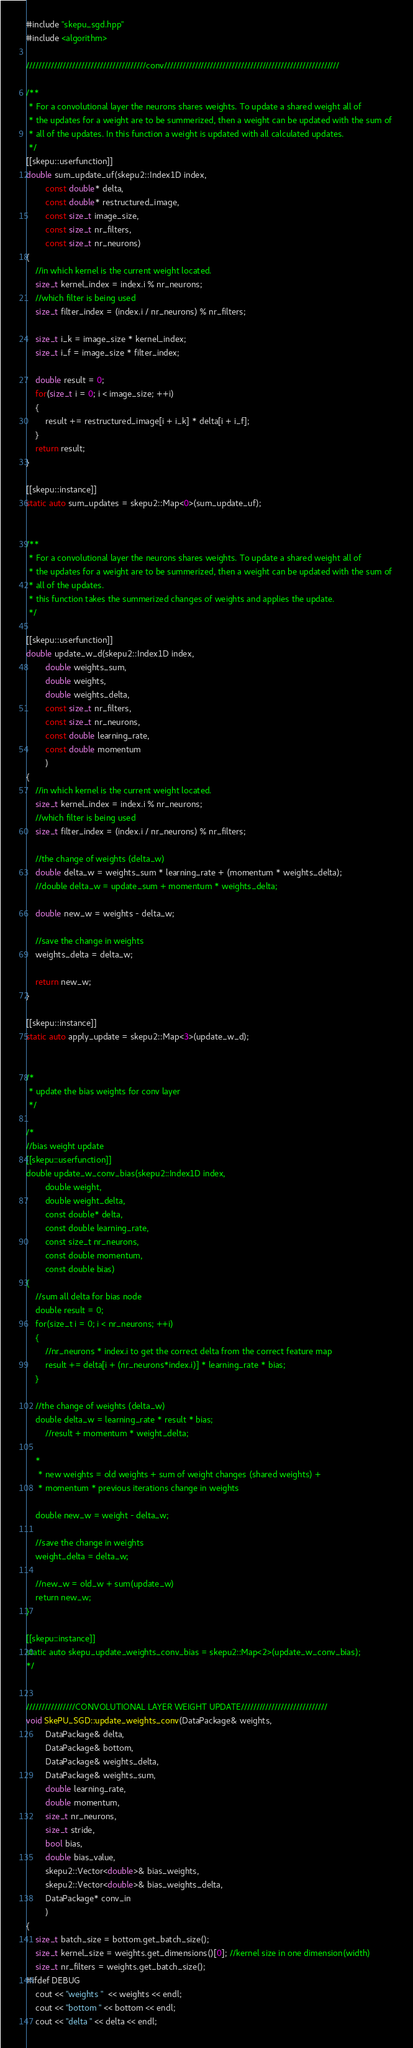<code> <loc_0><loc_0><loc_500><loc_500><_C++_>#include "skepu_sgd.hpp"
#include <algorithm>

///////////////////////////////////////conv/////////////////////////////////////////////////////////

/**
 * For a convolutional layer the neurons shares weights. To update a shared weight all of
 * the updates for a weight are to be summerized, then a weight can be updated with the sum of 
 * all of the updates. In this function a weight is updated with all calculated updates.
 */
[[skepu::userfunction]]
double sum_update_uf(skepu2::Index1D index, 
		const double* delta, 
		const double* restructured_image,
        const size_t image_size,
		const size_t nr_filters,
		const size_t nr_neurons)
{
	//in which kernel is the current weight located.
	size_t kernel_index = index.i % nr_neurons;
	//which filter is being used
	size_t filter_index = (index.i / nr_neurons) % nr_filters;

    size_t i_k = image_size * kernel_index;
    size_t i_f = image_size * filter_index;

	double result = 0;
	for(size_t i = 0; i < image_size; ++i)
	{
		result += restructured_image[i + i_k] * delta[i + i_f];
	}
	return result;
}

[[skepu::instance]]
static auto sum_updates = skepu2::Map<0>(sum_update_uf);


/**
 * For a convolutional layer the neurons shares weights. To update a shared weight all of
 * the updates for a weight are to be summerized, then a weight can be updated with the sum of 
 * all of the updates.
 * this function takes the summerized changes of weights and applies the update.
 */

[[skepu::userfunction]]
double update_w_d(skepu2::Index1D index, 
        double weights_sum,
        double weights,
		double weights_delta,
		const size_t nr_filters,
		const size_t nr_neurons,
		const double learning_rate,
		const double momentum
        )
{
	//in which kernel is the current weight located.
	size_t kernel_index = index.i % nr_neurons;
	//which filter is being used
	size_t filter_index = (index.i / nr_neurons) % nr_filters;

	//the change of weights (delta_w)
    double delta_w = weights_sum * learning_rate + (momentum * weights_delta);
	//double delta_w = update_sum + momentum * weights_delta;

	double new_w = weights - delta_w;

	//save the change in weights
	weights_delta = delta_w;

	return new_w;
}

[[skepu::instance]]
static auto apply_update = skepu2::Map<3>(update_w_d);


/*
 * update the bias weights for conv layer
 */

/*
//bias weight update
[[skepu::userfunction]]
double update_w_conv_bias(skepu2::Index1D index, 
		double weight,
		double weight_delta,
		const double* delta,
		const double learning_rate,
		const size_t nr_neurons,
		const double momentum,
		const double bias)
{
	//sum all delta for bias node
	double result = 0;
	for(size_t i = 0; i < nr_neurons; ++i)
	{
		//nr_neurons * index.i to get the correct delta from the correct feature map
		result += delta[i + (nr_neurons*index.i)] * learning_rate * bias;
	}

	//the change of weights (delta_w)
	double delta_w = learning_rate * result * bias;
        //result + momentum * weight_delta;

	*
	 * new weights = old weights + sum of weight changes (shared weights) +
	 * momentum * previous iterations change in weights
	 
	double new_w = weight - delta_w;

	//save the change in weights
	weight_delta = delta_w;

	//new_w = old_w + sum(update_w)
	return new_w;
}

[[skepu::instance]]
static auto skepu_update_weights_conv_bias = skepu2::Map<2>(update_w_conv_bias);
*/


////////////////CONVOLUTIONAL LAYER WEIGHT UPDATE////////////////////////////
void SkePU_SGD::update_weights_conv(DataPackage& weights,
        DataPackage& delta,
        DataPackage& bottom,
        DataPackage& weights_delta,
        DataPackage& weights_sum,
		double learning_rate,
		double momentum,
        size_t nr_neurons,
        size_t stride,
		bool bias,
        double bias_value,
        skepu2::Vector<double>& bias_weights,
		skepu2::Vector<double>& bias_weights_delta,
        DataPackage* conv_in
        )
{
    size_t batch_size = bottom.get_batch_size();
    size_t kernel_size = weights.get_dimensions()[0]; //kernel size in one dimension(width)
    size_t nr_filters = weights.get_batch_size();
#ifdef DEBUG 
	cout << "weights "  << weights << endl;
	cout << "bottom " << bottom << endl;
	cout << "delta " << delta << endl;</code> 